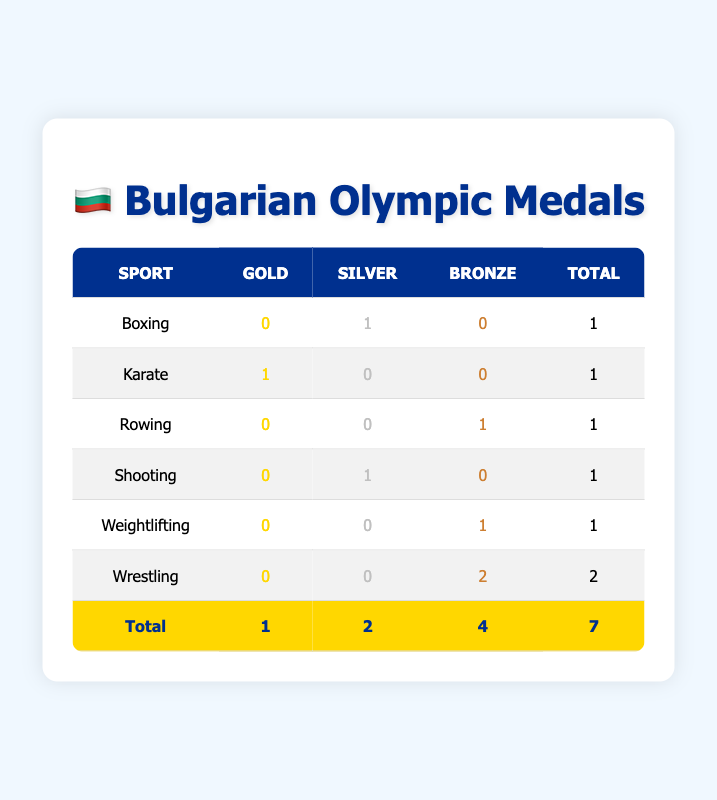What is the total number of medals won by Bulgarian athletes? The table shows a row labeled "Total" which aggregates the medal counts. The total number of medals is the last column of that row, which indicates there are 7 medals.
Answer: 7 In how many sports did Bulgarian athletes win medals? By looking at the table, we can count the number of unique sports listed in the first column. The sports are Boxing, Karate, Rowing, Shooting, Weightlifting, and Wrestling, giving us a total of 6 sports with medals.
Answer: 6 Which sport had the highest number of silver medals? From the table, we look at the "Silver" column to find the highest value. The sport with the most silver medals is Wrestling, with 2 silver medals.
Answer: Wrestling Did Bulgarian athletes win any gold medals in Boxing? Checking the "Gold" column for Boxing, we see a value of 0, indicating no gold medals were won in this sport.
Answer: No What is the total number of bronze medals won in Weightlifting and Rowing combined? We look in the "Bronze" column for both Weightlifting and Rowing. Weightlifting has 1 bronze medal, and Rowing also has 1 bronze medal. Adding those together gives 1 + 1 = 2 bronze medals in total.
Answer: 2 Is it true that Bulgarian athletes won more silver medals than gold medals? To verify this, we compare the totals in the "Silver" and "Gold" columns. The total silver medals are 2, and the gold medals are 1. Since 2 is greater than 1, the statement is true.
Answer: Yes What percentage of the total medals were bronze? The total number of bronze medals is 4 as seen in the "Total" row. The total number of medals is 7. To find the percentage, we calculate (4/7) * 100, which results in approximately 57.14%.
Answer: Approximately 57.14% Which sport contributed the most to the total number of bronze medals? By examining the "Bronze" column, we find the highest value is 2, which corresponds to Wrestling. Therefore, Wrestling contributed the most to the total bronze medals.
Answer: Wrestling How many sports did not win any gold medals? By scanning the "Gold" column, we see that Boxing, Rowing, Shooting, Weightlifting, and Wrestling all have 0 gold medals. Counting these gives us 5 sports that did not win any gold medals.
Answer: 5 